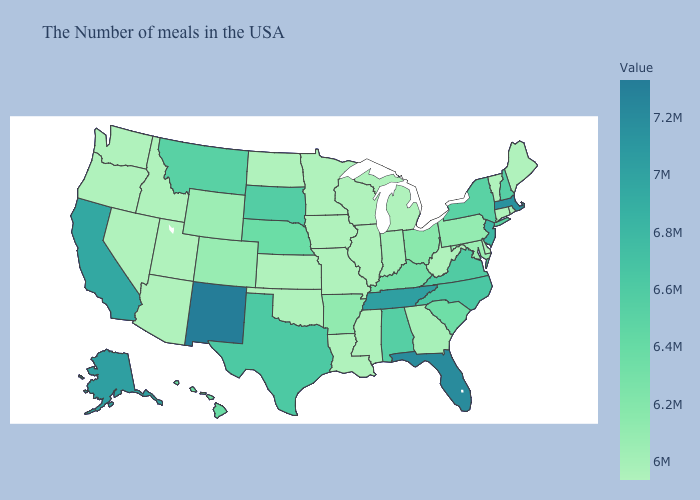Is the legend a continuous bar?
Answer briefly. Yes. Does Alabama have the highest value in the USA?
Short answer required. No. Does New Jersey have the lowest value in the USA?
Be succinct. No. Does the map have missing data?
Concise answer only. No. Does South Dakota have the highest value in the MidWest?
Answer briefly. Yes. Which states hav the highest value in the MidWest?
Give a very brief answer. South Dakota. Among the states that border Vermont , which have the highest value?
Concise answer only. Massachusetts. Among the states that border South Dakota , does Iowa have the highest value?
Give a very brief answer. No. 